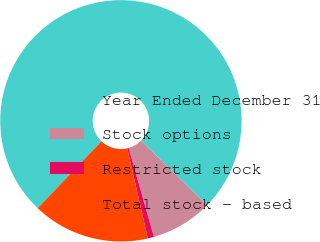<chart> <loc_0><loc_0><loc_500><loc_500><pie_chart><fcel>Year Ended December 31<fcel>Stock options<fcel>Restricted stock<fcel>Total stock - based<nl><fcel>75.21%<fcel>8.26%<fcel>0.82%<fcel>15.7%<nl></chart> 